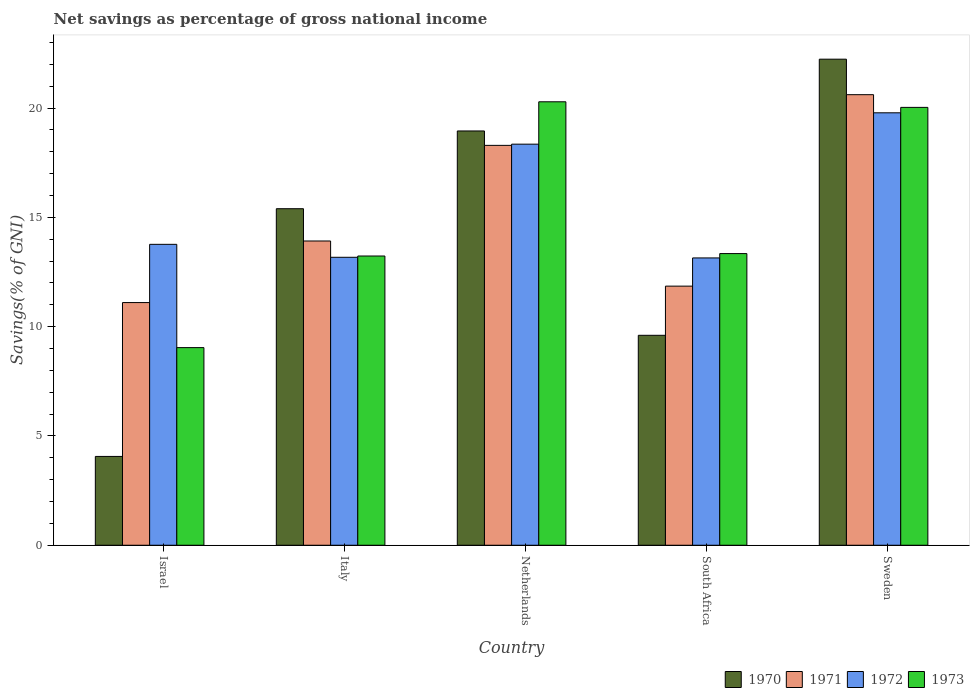How many different coloured bars are there?
Your response must be concise. 4. How many groups of bars are there?
Provide a succinct answer. 5. Are the number of bars on each tick of the X-axis equal?
Your answer should be compact. Yes. What is the label of the 4th group of bars from the left?
Provide a succinct answer. South Africa. What is the total savings in 1970 in South Africa?
Your response must be concise. 9.6. Across all countries, what is the maximum total savings in 1973?
Your answer should be very brief. 20.29. Across all countries, what is the minimum total savings in 1972?
Your answer should be very brief. 13.14. In which country was the total savings in 1972 minimum?
Your answer should be compact. South Africa. What is the total total savings in 1972 in the graph?
Give a very brief answer. 78.22. What is the difference between the total savings in 1971 in Israel and that in Sweden?
Ensure brevity in your answer.  -9.51. What is the difference between the total savings in 1973 in Sweden and the total savings in 1970 in Italy?
Your answer should be compact. 4.64. What is the average total savings in 1971 per country?
Offer a very short reply. 15.16. What is the difference between the total savings of/in 1971 and total savings of/in 1970 in South Africa?
Provide a succinct answer. 2.25. In how many countries, is the total savings in 1970 greater than 3 %?
Offer a very short reply. 5. What is the ratio of the total savings in 1972 in Netherlands to that in Sweden?
Offer a very short reply. 0.93. Is the total savings in 1970 in Italy less than that in Sweden?
Provide a short and direct response. Yes. Is the difference between the total savings in 1971 in South Africa and Sweden greater than the difference between the total savings in 1970 in South Africa and Sweden?
Your answer should be compact. Yes. What is the difference between the highest and the second highest total savings in 1970?
Your response must be concise. -3.28. What is the difference between the highest and the lowest total savings in 1973?
Give a very brief answer. 11.25. In how many countries, is the total savings in 1970 greater than the average total savings in 1970 taken over all countries?
Provide a succinct answer. 3. Is the sum of the total savings in 1972 in Italy and South Africa greater than the maximum total savings in 1971 across all countries?
Provide a succinct answer. Yes. Is it the case that in every country, the sum of the total savings in 1973 and total savings in 1971 is greater than the sum of total savings in 1972 and total savings in 1970?
Ensure brevity in your answer.  No. What does the 2nd bar from the right in Sweden represents?
Offer a terse response. 1972. How many bars are there?
Make the answer very short. 20. What is the difference between two consecutive major ticks on the Y-axis?
Provide a succinct answer. 5. Does the graph contain any zero values?
Your answer should be very brief. No. Does the graph contain grids?
Keep it short and to the point. No. How many legend labels are there?
Your response must be concise. 4. What is the title of the graph?
Your answer should be compact. Net savings as percentage of gross national income. Does "1967" appear as one of the legend labels in the graph?
Provide a succinct answer. No. What is the label or title of the Y-axis?
Offer a very short reply. Savings(% of GNI). What is the Savings(% of GNI) of 1970 in Israel?
Give a very brief answer. 4.06. What is the Savings(% of GNI) in 1971 in Israel?
Provide a short and direct response. 11.1. What is the Savings(% of GNI) in 1972 in Israel?
Provide a succinct answer. 13.77. What is the Savings(% of GNI) of 1973 in Israel?
Your response must be concise. 9.04. What is the Savings(% of GNI) in 1970 in Italy?
Provide a succinct answer. 15.4. What is the Savings(% of GNI) of 1971 in Italy?
Your response must be concise. 13.92. What is the Savings(% of GNI) of 1972 in Italy?
Give a very brief answer. 13.17. What is the Savings(% of GNI) in 1973 in Italy?
Your response must be concise. 13.23. What is the Savings(% of GNI) in 1970 in Netherlands?
Offer a terse response. 18.95. What is the Savings(% of GNI) of 1971 in Netherlands?
Your response must be concise. 18.29. What is the Savings(% of GNI) of 1972 in Netherlands?
Offer a very short reply. 18.35. What is the Savings(% of GNI) in 1973 in Netherlands?
Give a very brief answer. 20.29. What is the Savings(% of GNI) of 1970 in South Africa?
Ensure brevity in your answer.  9.6. What is the Savings(% of GNI) of 1971 in South Africa?
Make the answer very short. 11.85. What is the Savings(% of GNI) of 1972 in South Africa?
Offer a very short reply. 13.14. What is the Savings(% of GNI) in 1973 in South Africa?
Provide a succinct answer. 13.34. What is the Savings(% of GNI) in 1970 in Sweden?
Offer a very short reply. 22.24. What is the Savings(% of GNI) of 1971 in Sweden?
Your answer should be compact. 20.61. What is the Savings(% of GNI) in 1972 in Sweden?
Provide a succinct answer. 19.78. What is the Savings(% of GNI) of 1973 in Sweden?
Keep it short and to the point. 20.03. Across all countries, what is the maximum Savings(% of GNI) in 1970?
Give a very brief answer. 22.24. Across all countries, what is the maximum Savings(% of GNI) in 1971?
Offer a very short reply. 20.61. Across all countries, what is the maximum Savings(% of GNI) in 1972?
Offer a terse response. 19.78. Across all countries, what is the maximum Savings(% of GNI) in 1973?
Provide a short and direct response. 20.29. Across all countries, what is the minimum Savings(% of GNI) of 1970?
Your answer should be very brief. 4.06. Across all countries, what is the minimum Savings(% of GNI) of 1971?
Your response must be concise. 11.1. Across all countries, what is the minimum Savings(% of GNI) in 1972?
Provide a short and direct response. 13.14. Across all countries, what is the minimum Savings(% of GNI) of 1973?
Make the answer very short. 9.04. What is the total Savings(% of GNI) in 1970 in the graph?
Give a very brief answer. 70.25. What is the total Savings(% of GNI) in 1971 in the graph?
Keep it short and to the point. 75.78. What is the total Savings(% of GNI) in 1972 in the graph?
Offer a very short reply. 78.22. What is the total Savings(% of GNI) in 1973 in the graph?
Your response must be concise. 75.93. What is the difference between the Savings(% of GNI) in 1970 in Israel and that in Italy?
Make the answer very short. -11.33. What is the difference between the Savings(% of GNI) in 1971 in Israel and that in Italy?
Your response must be concise. -2.82. What is the difference between the Savings(% of GNI) of 1972 in Israel and that in Italy?
Offer a very short reply. 0.59. What is the difference between the Savings(% of GNI) of 1973 in Israel and that in Italy?
Keep it short and to the point. -4.19. What is the difference between the Savings(% of GNI) in 1970 in Israel and that in Netherlands?
Keep it short and to the point. -14.89. What is the difference between the Savings(% of GNI) of 1971 in Israel and that in Netherlands?
Keep it short and to the point. -7.19. What is the difference between the Savings(% of GNI) in 1972 in Israel and that in Netherlands?
Provide a succinct answer. -4.58. What is the difference between the Savings(% of GNI) of 1973 in Israel and that in Netherlands?
Offer a very short reply. -11.25. What is the difference between the Savings(% of GNI) of 1970 in Israel and that in South Africa?
Offer a very short reply. -5.54. What is the difference between the Savings(% of GNI) of 1971 in Israel and that in South Africa?
Offer a terse response. -0.75. What is the difference between the Savings(% of GNI) of 1972 in Israel and that in South Africa?
Provide a short and direct response. 0.62. What is the difference between the Savings(% of GNI) in 1973 in Israel and that in South Africa?
Give a very brief answer. -4.3. What is the difference between the Savings(% of GNI) of 1970 in Israel and that in Sweden?
Your answer should be compact. -18.17. What is the difference between the Savings(% of GNI) in 1971 in Israel and that in Sweden?
Ensure brevity in your answer.  -9.51. What is the difference between the Savings(% of GNI) of 1972 in Israel and that in Sweden?
Offer a terse response. -6.02. What is the difference between the Savings(% of GNI) in 1973 in Israel and that in Sweden?
Your answer should be very brief. -10.99. What is the difference between the Savings(% of GNI) of 1970 in Italy and that in Netherlands?
Give a very brief answer. -3.56. What is the difference between the Savings(% of GNI) in 1971 in Italy and that in Netherlands?
Ensure brevity in your answer.  -4.37. What is the difference between the Savings(% of GNI) in 1972 in Italy and that in Netherlands?
Your answer should be very brief. -5.18. What is the difference between the Savings(% of GNI) of 1973 in Italy and that in Netherlands?
Make the answer very short. -7.06. What is the difference between the Savings(% of GNI) in 1970 in Italy and that in South Africa?
Provide a succinct answer. 5.79. What is the difference between the Savings(% of GNI) of 1971 in Italy and that in South Africa?
Keep it short and to the point. 2.07. What is the difference between the Savings(% of GNI) in 1972 in Italy and that in South Africa?
Give a very brief answer. 0.03. What is the difference between the Savings(% of GNI) of 1973 in Italy and that in South Africa?
Your answer should be very brief. -0.11. What is the difference between the Savings(% of GNI) of 1970 in Italy and that in Sweden?
Ensure brevity in your answer.  -6.84. What is the difference between the Savings(% of GNI) of 1971 in Italy and that in Sweden?
Give a very brief answer. -6.69. What is the difference between the Savings(% of GNI) of 1972 in Italy and that in Sweden?
Ensure brevity in your answer.  -6.61. What is the difference between the Savings(% of GNI) of 1973 in Italy and that in Sweden?
Offer a very short reply. -6.8. What is the difference between the Savings(% of GNI) in 1970 in Netherlands and that in South Africa?
Offer a very short reply. 9.35. What is the difference between the Savings(% of GNI) in 1971 in Netherlands and that in South Africa?
Offer a very short reply. 6.44. What is the difference between the Savings(% of GNI) in 1972 in Netherlands and that in South Africa?
Give a very brief answer. 5.21. What is the difference between the Savings(% of GNI) in 1973 in Netherlands and that in South Africa?
Your response must be concise. 6.95. What is the difference between the Savings(% of GNI) of 1970 in Netherlands and that in Sweden?
Give a very brief answer. -3.28. What is the difference between the Savings(% of GNI) in 1971 in Netherlands and that in Sweden?
Your answer should be very brief. -2.32. What is the difference between the Savings(% of GNI) in 1972 in Netherlands and that in Sweden?
Make the answer very short. -1.43. What is the difference between the Savings(% of GNI) in 1973 in Netherlands and that in Sweden?
Your answer should be compact. 0.26. What is the difference between the Savings(% of GNI) of 1970 in South Africa and that in Sweden?
Give a very brief answer. -12.63. What is the difference between the Savings(% of GNI) in 1971 in South Africa and that in Sweden?
Provide a short and direct response. -8.76. What is the difference between the Savings(% of GNI) of 1972 in South Africa and that in Sweden?
Keep it short and to the point. -6.64. What is the difference between the Savings(% of GNI) of 1973 in South Africa and that in Sweden?
Provide a short and direct response. -6.69. What is the difference between the Savings(% of GNI) of 1970 in Israel and the Savings(% of GNI) of 1971 in Italy?
Your answer should be very brief. -9.86. What is the difference between the Savings(% of GNI) of 1970 in Israel and the Savings(% of GNI) of 1972 in Italy?
Keep it short and to the point. -9.11. What is the difference between the Savings(% of GNI) of 1970 in Israel and the Savings(% of GNI) of 1973 in Italy?
Offer a terse response. -9.17. What is the difference between the Savings(% of GNI) of 1971 in Israel and the Savings(% of GNI) of 1972 in Italy?
Offer a very short reply. -2.07. What is the difference between the Savings(% of GNI) of 1971 in Israel and the Savings(% of GNI) of 1973 in Italy?
Ensure brevity in your answer.  -2.13. What is the difference between the Savings(% of GNI) in 1972 in Israel and the Savings(% of GNI) in 1973 in Italy?
Provide a short and direct response. 0.53. What is the difference between the Savings(% of GNI) in 1970 in Israel and the Savings(% of GNI) in 1971 in Netherlands?
Keep it short and to the point. -14.23. What is the difference between the Savings(% of GNI) in 1970 in Israel and the Savings(% of GNI) in 1972 in Netherlands?
Make the answer very short. -14.29. What is the difference between the Savings(% of GNI) in 1970 in Israel and the Savings(% of GNI) in 1973 in Netherlands?
Provide a succinct answer. -16.22. What is the difference between the Savings(% of GNI) in 1971 in Israel and the Savings(% of GNI) in 1972 in Netherlands?
Offer a very short reply. -7.25. What is the difference between the Savings(% of GNI) of 1971 in Israel and the Savings(% of GNI) of 1973 in Netherlands?
Make the answer very short. -9.19. What is the difference between the Savings(% of GNI) of 1972 in Israel and the Savings(% of GNI) of 1973 in Netherlands?
Ensure brevity in your answer.  -6.52. What is the difference between the Savings(% of GNI) in 1970 in Israel and the Savings(% of GNI) in 1971 in South Africa?
Make the answer very short. -7.79. What is the difference between the Savings(% of GNI) in 1970 in Israel and the Savings(% of GNI) in 1972 in South Africa?
Your answer should be compact. -9.08. What is the difference between the Savings(% of GNI) of 1970 in Israel and the Savings(% of GNI) of 1973 in South Africa?
Provide a succinct answer. -9.28. What is the difference between the Savings(% of GNI) in 1971 in Israel and the Savings(% of GNI) in 1972 in South Africa?
Provide a short and direct response. -2.04. What is the difference between the Savings(% of GNI) of 1971 in Israel and the Savings(% of GNI) of 1973 in South Africa?
Give a very brief answer. -2.24. What is the difference between the Savings(% of GNI) of 1972 in Israel and the Savings(% of GNI) of 1973 in South Africa?
Your response must be concise. 0.42. What is the difference between the Savings(% of GNI) in 1970 in Israel and the Savings(% of GNI) in 1971 in Sweden?
Your response must be concise. -16.55. What is the difference between the Savings(% of GNI) in 1970 in Israel and the Savings(% of GNI) in 1972 in Sweden?
Provide a short and direct response. -15.72. What is the difference between the Savings(% of GNI) in 1970 in Israel and the Savings(% of GNI) in 1973 in Sweden?
Provide a succinct answer. -15.97. What is the difference between the Savings(% of GNI) of 1971 in Israel and the Savings(% of GNI) of 1972 in Sweden?
Offer a terse response. -8.68. What is the difference between the Savings(% of GNI) of 1971 in Israel and the Savings(% of GNI) of 1973 in Sweden?
Make the answer very short. -8.93. What is the difference between the Savings(% of GNI) of 1972 in Israel and the Savings(% of GNI) of 1973 in Sweden?
Your response must be concise. -6.27. What is the difference between the Savings(% of GNI) of 1970 in Italy and the Savings(% of GNI) of 1971 in Netherlands?
Provide a short and direct response. -2.9. What is the difference between the Savings(% of GNI) in 1970 in Italy and the Savings(% of GNI) in 1972 in Netherlands?
Provide a short and direct response. -2.95. What is the difference between the Savings(% of GNI) of 1970 in Italy and the Savings(% of GNI) of 1973 in Netherlands?
Your response must be concise. -4.89. What is the difference between the Savings(% of GNI) of 1971 in Italy and the Savings(% of GNI) of 1972 in Netherlands?
Your answer should be very brief. -4.43. What is the difference between the Savings(% of GNI) in 1971 in Italy and the Savings(% of GNI) in 1973 in Netherlands?
Make the answer very short. -6.37. What is the difference between the Savings(% of GNI) in 1972 in Italy and the Savings(% of GNI) in 1973 in Netherlands?
Give a very brief answer. -7.11. What is the difference between the Savings(% of GNI) of 1970 in Italy and the Savings(% of GNI) of 1971 in South Africa?
Your response must be concise. 3.54. What is the difference between the Savings(% of GNI) of 1970 in Italy and the Savings(% of GNI) of 1972 in South Africa?
Ensure brevity in your answer.  2.25. What is the difference between the Savings(% of GNI) in 1970 in Italy and the Savings(% of GNI) in 1973 in South Africa?
Provide a short and direct response. 2.05. What is the difference between the Savings(% of GNI) of 1971 in Italy and the Savings(% of GNI) of 1972 in South Africa?
Your answer should be compact. 0.78. What is the difference between the Savings(% of GNI) in 1971 in Italy and the Savings(% of GNI) in 1973 in South Africa?
Offer a very short reply. 0.58. What is the difference between the Savings(% of GNI) of 1972 in Italy and the Savings(% of GNI) of 1973 in South Africa?
Your answer should be very brief. -0.17. What is the difference between the Savings(% of GNI) in 1970 in Italy and the Savings(% of GNI) in 1971 in Sweden?
Provide a succinct answer. -5.22. What is the difference between the Savings(% of GNI) in 1970 in Italy and the Savings(% of GNI) in 1972 in Sweden?
Give a very brief answer. -4.39. What is the difference between the Savings(% of GNI) of 1970 in Italy and the Savings(% of GNI) of 1973 in Sweden?
Provide a short and direct response. -4.64. What is the difference between the Savings(% of GNI) in 1971 in Italy and the Savings(% of GNI) in 1972 in Sweden?
Offer a very short reply. -5.86. What is the difference between the Savings(% of GNI) in 1971 in Italy and the Savings(% of GNI) in 1973 in Sweden?
Make the answer very short. -6.11. What is the difference between the Savings(% of GNI) of 1972 in Italy and the Savings(% of GNI) of 1973 in Sweden?
Your response must be concise. -6.86. What is the difference between the Savings(% of GNI) of 1970 in Netherlands and the Savings(% of GNI) of 1971 in South Africa?
Ensure brevity in your answer.  7.1. What is the difference between the Savings(% of GNI) of 1970 in Netherlands and the Savings(% of GNI) of 1972 in South Africa?
Provide a short and direct response. 5.81. What is the difference between the Savings(% of GNI) of 1970 in Netherlands and the Savings(% of GNI) of 1973 in South Africa?
Offer a very short reply. 5.61. What is the difference between the Savings(% of GNI) of 1971 in Netherlands and the Savings(% of GNI) of 1972 in South Africa?
Your answer should be compact. 5.15. What is the difference between the Savings(% of GNI) of 1971 in Netherlands and the Savings(% of GNI) of 1973 in South Africa?
Offer a terse response. 4.95. What is the difference between the Savings(% of GNI) of 1972 in Netherlands and the Savings(% of GNI) of 1973 in South Africa?
Your answer should be very brief. 5.01. What is the difference between the Savings(% of GNI) of 1970 in Netherlands and the Savings(% of GNI) of 1971 in Sweden?
Keep it short and to the point. -1.66. What is the difference between the Savings(% of GNI) in 1970 in Netherlands and the Savings(% of GNI) in 1972 in Sweden?
Give a very brief answer. -0.83. What is the difference between the Savings(% of GNI) of 1970 in Netherlands and the Savings(% of GNI) of 1973 in Sweden?
Offer a terse response. -1.08. What is the difference between the Savings(% of GNI) in 1971 in Netherlands and the Savings(% of GNI) in 1972 in Sweden?
Offer a terse response. -1.49. What is the difference between the Savings(% of GNI) in 1971 in Netherlands and the Savings(% of GNI) in 1973 in Sweden?
Give a very brief answer. -1.74. What is the difference between the Savings(% of GNI) of 1972 in Netherlands and the Savings(% of GNI) of 1973 in Sweden?
Provide a short and direct response. -1.68. What is the difference between the Savings(% of GNI) in 1970 in South Africa and the Savings(% of GNI) in 1971 in Sweden?
Your response must be concise. -11.01. What is the difference between the Savings(% of GNI) in 1970 in South Africa and the Savings(% of GNI) in 1972 in Sweden?
Your answer should be very brief. -10.18. What is the difference between the Savings(% of GNI) of 1970 in South Africa and the Savings(% of GNI) of 1973 in Sweden?
Ensure brevity in your answer.  -10.43. What is the difference between the Savings(% of GNI) of 1971 in South Africa and the Savings(% of GNI) of 1972 in Sweden?
Offer a very short reply. -7.93. What is the difference between the Savings(% of GNI) of 1971 in South Africa and the Savings(% of GNI) of 1973 in Sweden?
Provide a short and direct response. -8.18. What is the difference between the Savings(% of GNI) in 1972 in South Africa and the Savings(% of GNI) in 1973 in Sweden?
Your answer should be very brief. -6.89. What is the average Savings(% of GNI) of 1970 per country?
Your response must be concise. 14.05. What is the average Savings(% of GNI) of 1971 per country?
Provide a succinct answer. 15.16. What is the average Savings(% of GNI) of 1972 per country?
Your answer should be very brief. 15.64. What is the average Savings(% of GNI) of 1973 per country?
Offer a terse response. 15.19. What is the difference between the Savings(% of GNI) of 1970 and Savings(% of GNI) of 1971 in Israel?
Your answer should be compact. -7.04. What is the difference between the Savings(% of GNI) in 1970 and Savings(% of GNI) in 1972 in Israel?
Provide a short and direct response. -9.7. What is the difference between the Savings(% of GNI) in 1970 and Savings(% of GNI) in 1973 in Israel?
Ensure brevity in your answer.  -4.98. What is the difference between the Savings(% of GNI) in 1971 and Savings(% of GNI) in 1972 in Israel?
Offer a very short reply. -2.66. What is the difference between the Savings(% of GNI) of 1971 and Savings(% of GNI) of 1973 in Israel?
Offer a very short reply. 2.06. What is the difference between the Savings(% of GNI) in 1972 and Savings(% of GNI) in 1973 in Israel?
Provide a short and direct response. 4.73. What is the difference between the Savings(% of GNI) in 1970 and Savings(% of GNI) in 1971 in Italy?
Your answer should be very brief. 1.48. What is the difference between the Savings(% of GNI) of 1970 and Savings(% of GNI) of 1972 in Italy?
Provide a succinct answer. 2.22. What is the difference between the Savings(% of GNI) in 1970 and Savings(% of GNI) in 1973 in Italy?
Provide a succinct answer. 2.16. What is the difference between the Savings(% of GNI) in 1971 and Savings(% of GNI) in 1972 in Italy?
Make the answer very short. 0.75. What is the difference between the Savings(% of GNI) in 1971 and Savings(% of GNI) in 1973 in Italy?
Your answer should be compact. 0.69. What is the difference between the Savings(% of GNI) in 1972 and Savings(% of GNI) in 1973 in Italy?
Give a very brief answer. -0.06. What is the difference between the Savings(% of GNI) in 1970 and Savings(% of GNI) in 1971 in Netherlands?
Your answer should be very brief. 0.66. What is the difference between the Savings(% of GNI) in 1970 and Savings(% of GNI) in 1972 in Netherlands?
Provide a short and direct response. 0.6. What is the difference between the Savings(% of GNI) in 1970 and Savings(% of GNI) in 1973 in Netherlands?
Give a very brief answer. -1.33. What is the difference between the Savings(% of GNI) in 1971 and Savings(% of GNI) in 1972 in Netherlands?
Provide a short and direct response. -0.06. What is the difference between the Savings(% of GNI) in 1971 and Savings(% of GNI) in 1973 in Netherlands?
Your response must be concise. -1.99. What is the difference between the Savings(% of GNI) of 1972 and Savings(% of GNI) of 1973 in Netherlands?
Provide a short and direct response. -1.94. What is the difference between the Savings(% of GNI) in 1970 and Savings(% of GNI) in 1971 in South Africa?
Provide a succinct answer. -2.25. What is the difference between the Savings(% of GNI) in 1970 and Savings(% of GNI) in 1972 in South Africa?
Your answer should be compact. -3.54. What is the difference between the Savings(% of GNI) of 1970 and Savings(% of GNI) of 1973 in South Africa?
Offer a very short reply. -3.74. What is the difference between the Savings(% of GNI) in 1971 and Savings(% of GNI) in 1972 in South Africa?
Give a very brief answer. -1.29. What is the difference between the Savings(% of GNI) in 1971 and Savings(% of GNI) in 1973 in South Africa?
Provide a short and direct response. -1.49. What is the difference between the Savings(% of GNI) of 1972 and Savings(% of GNI) of 1973 in South Africa?
Provide a succinct answer. -0.2. What is the difference between the Savings(% of GNI) in 1970 and Savings(% of GNI) in 1971 in Sweden?
Provide a succinct answer. 1.62. What is the difference between the Savings(% of GNI) in 1970 and Savings(% of GNI) in 1972 in Sweden?
Your response must be concise. 2.45. What is the difference between the Savings(% of GNI) of 1970 and Savings(% of GNI) of 1973 in Sweden?
Your response must be concise. 2.21. What is the difference between the Savings(% of GNI) of 1971 and Savings(% of GNI) of 1972 in Sweden?
Give a very brief answer. 0.83. What is the difference between the Savings(% of GNI) of 1971 and Savings(% of GNI) of 1973 in Sweden?
Provide a succinct answer. 0.58. What is the difference between the Savings(% of GNI) in 1972 and Savings(% of GNI) in 1973 in Sweden?
Offer a terse response. -0.25. What is the ratio of the Savings(% of GNI) of 1970 in Israel to that in Italy?
Offer a very short reply. 0.26. What is the ratio of the Savings(% of GNI) in 1971 in Israel to that in Italy?
Keep it short and to the point. 0.8. What is the ratio of the Savings(% of GNI) of 1972 in Israel to that in Italy?
Your response must be concise. 1.04. What is the ratio of the Savings(% of GNI) in 1973 in Israel to that in Italy?
Keep it short and to the point. 0.68. What is the ratio of the Savings(% of GNI) of 1970 in Israel to that in Netherlands?
Provide a short and direct response. 0.21. What is the ratio of the Savings(% of GNI) in 1971 in Israel to that in Netherlands?
Offer a terse response. 0.61. What is the ratio of the Savings(% of GNI) in 1972 in Israel to that in Netherlands?
Your response must be concise. 0.75. What is the ratio of the Savings(% of GNI) in 1973 in Israel to that in Netherlands?
Your answer should be very brief. 0.45. What is the ratio of the Savings(% of GNI) of 1970 in Israel to that in South Africa?
Your response must be concise. 0.42. What is the ratio of the Savings(% of GNI) of 1971 in Israel to that in South Africa?
Your answer should be compact. 0.94. What is the ratio of the Savings(% of GNI) in 1972 in Israel to that in South Africa?
Provide a succinct answer. 1.05. What is the ratio of the Savings(% of GNI) of 1973 in Israel to that in South Africa?
Provide a short and direct response. 0.68. What is the ratio of the Savings(% of GNI) of 1970 in Israel to that in Sweden?
Keep it short and to the point. 0.18. What is the ratio of the Savings(% of GNI) in 1971 in Israel to that in Sweden?
Give a very brief answer. 0.54. What is the ratio of the Savings(% of GNI) in 1972 in Israel to that in Sweden?
Give a very brief answer. 0.7. What is the ratio of the Savings(% of GNI) in 1973 in Israel to that in Sweden?
Give a very brief answer. 0.45. What is the ratio of the Savings(% of GNI) in 1970 in Italy to that in Netherlands?
Make the answer very short. 0.81. What is the ratio of the Savings(% of GNI) in 1971 in Italy to that in Netherlands?
Ensure brevity in your answer.  0.76. What is the ratio of the Savings(% of GNI) of 1972 in Italy to that in Netherlands?
Provide a succinct answer. 0.72. What is the ratio of the Savings(% of GNI) in 1973 in Italy to that in Netherlands?
Give a very brief answer. 0.65. What is the ratio of the Savings(% of GNI) of 1970 in Italy to that in South Africa?
Make the answer very short. 1.6. What is the ratio of the Savings(% of GNI) of 1971 in Italy to that in South Africa?
Your answer should be very brief. 1.17. What is the ratio of the Savings(% of GNI) in 1970 in Italy to that in Sweden?
Offer a very short reply. 0.69. What is the ratio of the Savings(% of GNI) of 1971 in Italy to that in Sweden?
Provide a succinct answer. 0.68. What is the ratio of the Savings(% of GNI) in 1972 in Italy to that in Sweden?
Make the answer very short. 0.67. What is the ratio of the Savings(% of GNI) in 1973 in Italy to that in Sweden?
Your response must be concise. 0.66. What is the ratio of the Savings(% of GNI) in 1970 in Netherlands to that in South Africa?
Your answer should be very brief. 1.97. What is the ratio of the Savings(% of GNI) of 1971 in Netherlands to that in South Africa?
Your answer should be very brief. 1.54. What is the ratio of the Savings(% of GNI) in 1972 in Netherlands to that in South Africa?
Keep it short and to the point. 1.4. What is the ratio of the Savings(% of GNI) of 1973 in Netherlands to that in South Africa?
Offer a very short reply. 1.52. What is the ratio of the Savings(% of GNI) of 1970 in Netherlands to that in Sweden?
Keep it short and to the point. 0.85. What is the ratio of the Savings(% of GNI) in 1971 in Netherlands to that in Sweden?
Keep it short and to the point. 0.89. What is the ratio of the Savings(% of GNI) in 1972 in Netherlands to that in Sweden?
Your answer should be very brief. 0.93. What is the ratio of the Savings(% of GNI) of 1973 in Netherlands to that in Sweden?
Your answer should be compact. 1.01. What is the ratio of the Savings(% of GNI) of 1970 in South Africa to that in Sweden?
Provide a short and direct response. 0.43. What is the ratio of the Savings(% of GNI) of 1971 in South Africa to that in Sweden?
Ensure brevity in your answer.  0.58. What is the ratio of the Savings(% of GNI) in 1972 in South Africa to that in Sweden?
Keep it short and to the point. 0.66. What is the ratio of the Savings(% of GNI) in 1973 in South Africa to that in Sweden?
Provide a succinct answer. 0.67. What is the difference between the highest and the second highest Savings(% of GNI) in 1970?
Offer a terse response. 3.28. What is the difference between the highest and the second highest Savings(% of GNI) of 1971?
Your response must be concise. 2.32. What is the difference between the highest and the second highest Savings(% of GNI) in 1972?
Your response must be concise. 1.43. What is the difference between the highest and the second highest Savings(% of GNI) in 1973?
Keep it short and to the point. 0.26. What is the difference between the highest and the lowest Savings(% of GNI) in 1970?
Provide a short and direct response. 18.17. What is the difference between the highest and the lowest Savings(% of GNI) of 1971?
Offer a terse response. 9.51. What is the difference between the highest and the lowest Savings(% of GNI) of 1972?
Make the answer very short. 6.64. What is the difference between the highest and the lowest Savings(% of GNI) of 1973?
Ensure brevity in your answer.  11.25. 